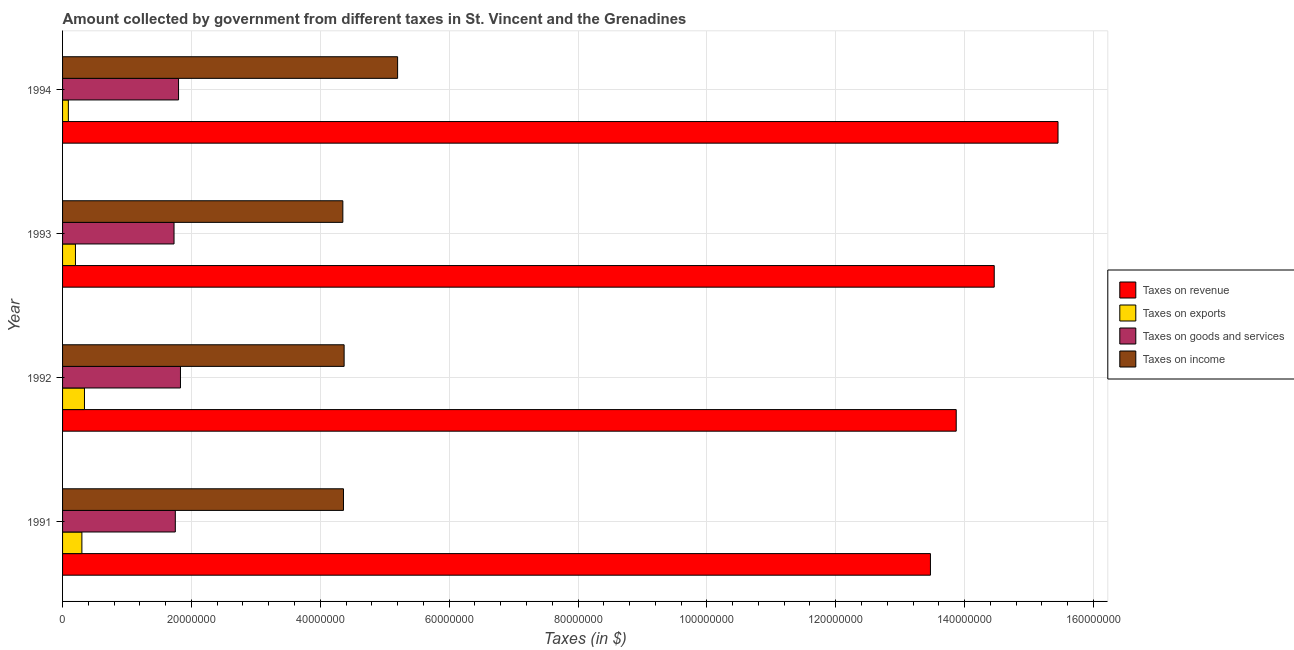How many different coloured bars are there?
Make the answer very short. 4. Are the number of bars per tick equal to the number of legend labels?
Offer a terse response. Yes. Are the number of bars on each tick of the Y-axis equal?
Give a very brief answer. Yes. How many bars are there on the 2nd tick from the top?
Offer a terse response. 4. How many bars are there on the 2nd tick from the bottom?
Your answer should be very brief. 4. What is the label of the 3rd group of bars from the top?
Provide a short and direct response. 1992. What is the amount collected as tax on revenue in 1991?
Your answer should be compact. 1.35e+08. Across all years, what is the maximum amount collected as tax on goods?
Offer a terse response. 1.83e+07. Across all years, what is the minimum amount collected as tax on goods?
Offer a very short reply. 1.73e+07. In which year was the amount collected as tax on revenue minimum?
Your answer should be very brief. 1991. What is the total amount collected as tax on income in the graph?
Your response must be concise. 1.83e+08. What is the difference between the amount collected as tax on goods in 1992 and that in 1994?
Your answer should be very brief. 3.00e+05. What is the difference between the amount collected as tax on exports in 1991 and the amount collected as tax on income in 1992?
Keep it short and to the point. -4.07e+07. What is the average amount collected as tax on goods per year?
Ensure brevity in your answer.  1.78e+07. In the year 1993, what is the difference between the amount collected as tax on exports and amount collected as tax on revenue?
Provide a short and direct response. -1.43e+08. Is the difference between the amount collected as tax on revenue in 1991 and 1994 greater than the difference between the amount collected as tax on exports in 1991 and 1994?
Keep it short and to the point. No. What is the difference between the highest and the second highest amount collected as tax on goods?
Keep it short and to the point. 3.00e+05. What is the difference between the highest and the lowest amount collected as tax on goods?
Your answer should be compact. 1.00e+06. What does the 4th bar from the top in 1993 represents?
Provide a succinct answer. Taxes on revenue. What does the 2nd bar from the bottom in 1992 represents?
Your response must be concise. Taxes on exports. Is it the case that in every year, the sum of the amount collected as tax on revenue and amount collected as tax on exports is greater than the amount collected as tax on goods?
Offer a very short reply. Yes. How many bars are there?
Give a very brief answer. 16. Are the values on the major ticks of X-axis written in scientific E-notation?
Keep it short and to the point. No. Does the graph contain grids?
Your answer should be very brief. Yes. Where does the legend appear in the graph?
Give a very brief answer. Center right. How many legend labels are there?
Make the answer very short. 4. How are the legend labels stacked?
Your answer should be very brief. Vertical. What is the title of the graph?
Keep it short and to the point. Amount collected by government from different taxes in St. Vincent and the Grenadines. What is the label or title of the X-axis?
Give a very brief answer. Taxes (in $). What is the label or title of the Y-axis?
Make the answer very short. Year. What is the Taxes (in $) in Taxes on revenue in 1991?
Your answer should be very brief. 1.35e+08. What is the Taxes (in $) in Taxes on goods and services in 1991?
Ensure brevity in your answer.  1.75e+07. What is the Taxes (in $) in Taxes on income in 1991?
Provide a succinct answer. 4.36e+07. What is the Taxes (in $) of Taxes on revenue in 1992?
Provide a short and direct response. 1.39e+08. What is the Taxes (in $) of Taxes on exports in 1992?
Keep it short and to the point. 3.40e+06. What is the Taxes (in $) in Taxes on goods and services in 1992?
Ensure brevity in your answer.  1.83e+07. What is the Taxes (in $) in Taxes on income in 1992?
Ensure brevity in your answer.  4.37e+07. What is the Taxes (in $) in Taxes on revenue in 1993?
Offer a very short reply. 1.45e+08. What is the Taxes (in $) in Taxes on goods and services in 1993?
Provide a succinct answer. 1.73e+07. What is the Taxes (in $) in Taxes on income in 1993?
Offer a very short reply. 4.35e+07. What is the Taxes (in $) in Taxes on revenue in 1994?
Provide a succinct answer. 1.54e+08. What is the Taxes (in $) in Taxes on exports in 1994?
Your answer should be compact. 9.00e+05. What is the Taxes (in $) of Taxes on goods and services in 1994?
Your answer should be compact. 1.80e+07. What is the Taxes (in $) in Taxes on income in 1994?
Make the answer very short. 5.20e+07. Across all years, what is the maximum Taxes (in $) in Taxes on revenue?
Provide a succinct answer. 1.54e+08. Across all years, what is the maximum Taxes (in $) in Taxes on exports?
Provide a succinct answer. 3.40e+06. Across all years, what is the maximum Taxes (in $) in Taxes on goods and services?
Keep it short and to the point. 1.83e+07. Across all years, what is the maximum Taxes (in $) of Taxes on income?
Your response must be concise. 5.20e+07. Across all years, what is the minimum Taxes (in $) in Taxes on revenue?
Make the answer very short. 1.35e+08. Across all years, what is the minimum Taxes (in $) in Taxes on goods and services?
Your answer should be compact. 1.73e+07. Across all years, what is the minimum Taxes (in $) in Taxes on income?
Ensure brevity in your answer.  4.35e+07. What is the total Taxes (in $) of Taxes on revenue in the graph?
Provide a succinct answer. 5.72e+08. What is the total Taxes (in $) of Taxes on exports in the graph?
Ensure brevity in your answer.  9.30e+06. What is the total Taxes (in $) of Taxes on goods and services in the graph?
Make the answer very short. 7.11e+07. What is the total Taxes (in $) of Taxes on income in the graph?
Provide a short and direct response. 1.83e+08. What is the difference between the Taxes (in $) of Taxes on exports in 1991 and that in 1992?
Your response must be concise. -4.00e+05. What is the difference between the Taxes (in $) of Taxes on goods and services in 1991 and that in 1992?
Provide a short and direct response. -8.00e+05. What is the difference between the Taxes (in $) of Taxes on income in 1991 and that in 1992?
Your answer should be very brief. -1.00e+05. What is the difference between the Taxes (in $) of Taxes on revenue in 1991 and that in 1993?
Your response must be concise. -9.90e+06. What is the difference between the Taxes (in $) of Taxes on exports in 1991 and that in 1993?
Ensure brevity in your answer.  1.00e+06. What is the difference between the Taxes (in $) of Taxes on income in 1991 and that in 1993?
Ensure brevity in your answer.  1.00e+05. What is the difference between the Taxes (in $) in Taxes on revenue in 1991 and that in 1994?
Your answer should be very brief. -1.98e+07. What is the difference between the Taxes (in $) of Taxes on exports in 1991 and that in 1994?
Provide a short and direct response. 2.10e+06. What is the difference between the Taxes (in $) of Taxes on goods and services in 1991 and that in 1994?
Your answer should be compact. -5.00e+05. What is the difference between the Taxes (in $) of Taxes on income in 1991 and that in 1994?
Ensure brevity in your answer.  -8.40e+06. What is the difference between the Taxes (in $) of Taxes on revenue in 1992 and that in 1993?
Keep it short and to the point. -5.90e+06. What is the difference between the Taxes (in $) of Taxes on exports in 1992 and that in 1993?
Your answer should be compact. 1.40e+06. What is the difference between the Taxes (in $) of Taxes on revenue in 1992 and that in 1994?
Your answer should be very brief. -1.58e+07. What is the difference between the Taxes (in $) of Taxes on exports in 1992 and that in 1994?
Provide a succinct answer. 2.50e+06. What is the difference between the Taxes (in $) in Taxes on goods and services in 1992 and that in 1994?
Offer a terse response. 3.00e+05. What is the difference between the Taxes (in $) in Taxes on income in 1992 and that in 1994?
Your answer should be compact. -8.30e+06. What is the difference between the Taxes (in $) in Taxes on revenue in 1993 and that in 1994?
Provide a short and direct response. -9.90e+06. What is the difference between the Taxes (in $) of Taxes on exports in 1993 and that in 1994?
Offer a very short reply. 1.10e+06. What is the difference between the Taxes (in $) in Taxes on goods and services in 1993 and that in 1994?
Give a very brief answer. -7.00e+05. What is the difference between the Taxes (in $) of Taxes on income in 1993 and that in 1994?
Ensure brevity in your answer.  -8.50e+06. What is the difference between the Taxes (in $) of Taxes on revenue in 1991 and the Taxes (in $) of Taxes on exports in 1992?
Ensure brevity in your answer.  1.31e+08. What is the difference between the Taxes (in $) in Taxes on revenue in 1991 and the Taxes (in $) in Taxes on goods and services in 1992?
Give a very brief answer. 1.16e+08. What is the difference between the Taxes (in $) of Taxes on revenue in 1991 and the Taxes (in $) of Taxes on income in 1992?
Your answer should be compact. 9.10e+07. What is the difference between the Taxes (in $) in Taxes on exports in 1991 and the Taxes (in $) in Taxes on goods and services in 1992?
Keep it short and to the point. -1.53e+07. What is the difference between the Taxes (in $) of Taxes on exports in 1991 and the Taxes (in $) of Taxes on income in 1992?
Offer a terse response. -4.07e+07. What is the difference between the Taxes (in $) in Taxes on goods and services in 1991 and the Taxes (in $) in Taxes on income in 1992?
Provide a short and direct response. -2.62e+07. What is the difference between the Taxes (in $) in Taxes on revenue in 1991 and the Taxes (in $) in Taxes on exports in 1993?
Offer a terse response. 1.33e+08. What is the difference between the Taxes (in $) in Taxes on revenue in 1991 and the Taxes (in $) in Taxes on goods and services in 1993?
Your response must be concise. 1.17e+08. What is the difference between the Taxes (in $) of Taxes on revenue in 1991 and the Taxes (in $) of Taxes on income in 1993?
Offer a terse response. 9.12e+07. What is the difference between the Taxes (in $) in Taxes on exports in 1991 and the Taxes (in $) in Taxes on goods and services in 1993?
Your answer should be very brief. -1.43e+07. What is the difference between the Taxes (in $) of Taxes on exports in 1991 and the Taxes (in $) of Taxes on income in 1993?
Provide a succinct answer. -4.05e+07. What is the difference between the Taxes (in $) of Taxes on goods and services in 1991 and the Taxes (in $) of Taxes on income in 1993?
Offer a very short reply. -2.60e+07. What is the difference between the Taxes (in $) of Taxes on revenue in 1991 and the Taxes (in $) of Taxes on exports in 1994?
Ensure brevity in your answer.  1.34e+08. What is the difference between the Taxes (in $) of Taxes on revenue in 1991 and the Taxes (in $) of Taxes on goods and services in 1994?
Offer a terse response. 1.17e+08. What is the difference between the Taxes (in $) of Taxes on revenue in 1991 and the Taxes (in $) of Taxes on income in 1994?
Your answer should be very brief. 8.27e+07. What is the difference between the Taxes (in $) in Taxes on exports in 1991 and the Taxes (in $) in Taxes on goods and services in 1994?
Your response must be concise. -1.50e+07. What is the difference between the Taxes (in $) in Taxes on exports in 1991 and the Taxes (in $) in Taxes on income in 1994?
Ensure brevity in your answer.  -4.90e+07. What is the difference between the Taxes (in $) of Taxes on goods and services in 1991 and the Taxes (in $) of Taxes on income in 1994?
Your answer should be very brief. -3.45e+07. What is the difference between the Taxes (in $) of Taxes on revenue in 1992 and the Taxes (in $) of Taxes on exports in 1993?
Keep it short and to the point. 1.37e+08. What is the difference between the Taxes (in $) of Taxes on revenue in 1992 and the Taxes (in $) of Taxes on goods and services in 1993?
Provide a short and direct response. 1.21e+08. What is the difference between the Taxes (in $) in Taxes on revenue in 1992 and the Taxes (in $) in Taxes on income in 1993?
Give a very brief answer. 9.52e+07. What is the difference between the Taxes (in $) in Taxes on exports in 1992 and the Taxes (in $) in Taxes on goods and services in 1993?
Provide a short and direct response. -1.39e+07. What is the difference between the Taxes (in $) of Taxes on exports in 1992 and the Taxes (in $) of Taxes on income in 1993?
Offer a very short reply. -4.01e+07. What is the difference between the Taxes (in $) of Taxes on goods and services in 1992 and the Taxes (in $) of Taxes on income in 1993?
Offer a terse response. -2.52e+07. What is the difference between the Taxes (in $) in Taxes on revenue in 1992 and the Taxes (in $) in Taxes on exports in 1994?
Offer a very short reply. 1.38e+08. What is the difference between the Taxes (in $) of Taxes on revenue in 1992 and the Taxes (in $) of Taxes on goods and services in 1994?
Provide a succinct answer. 1.21e+08. What is the difference between the Taxes (in $) in Taxes on revenue in 1992 and the Taxes (in $) in Taxes on income in 1994?
Your answer should be compact. 8.67e+07. What is the difference between the Taxes (in $) in Taxes on exports in 1992 and the Taxes (in $) in Taxes on goods and services in 1994?
Keep it short and to the point. -1.46e+07. What is the difference between the Taxes (in $) in Taxes on exports in 1992 and the Taxes (in $) in Taxes on income in 1994?
Ensure brevity in your answer.  -4.86e+07. What is the difference between the Taxes (in $) of Taxes on goods and services in 1992 and the Taxes (in $) of Taxes on income in 1994?
Make the answer very short. -3.37e+07. What is the difference between the Taxes (in $) of Taxes on revenue in 1993 and the Taxes (in $) of Taxes on exports in 1994?
Provide a succinct answer. 1.44e+08. What is the difference between the Taxes (in $) of Taxes on revenue in 1993 and the Taxes (in $) of Taxes on goods and services in 1994?
Your answer should be compact. 1.27e+08. What is the difference between the Taxes (in $) in Taxes on revenue in 1993 and the Taxes (in $) in Taxes on income in 1994?
Provide a succinct answer. 9.26e+07. What is the difference between the Taxes (in $) in Taxes on exports in 1993 and the Taxes (in $) in Taxes on goods and services in 1994?
Ensure brevity in your answer.  -1.60e+07. What is the difference between the Taxes (in $) of Taxes on exports in 1993 and the Taxes (in $) of Taxes on income in 1994?
Your answer should be very brief. -5.00e+07. What is the difference between the Taxes (in $) in Taxes on goods and services in 1993 and the Taxes (in $) in Taxes on income in 1994?
Your answer should be compact. -3.47e+07. What is the average Taxes (in $) in Taxes on revenue per year?
Give a very brief answer. 1.43e+08. What is the average Taxes (in $) in Taxes on exports per year?
Provide a succinct answer. 2.32e+06. What is the average Taxes (in $) of Taxes on goods and services per year?
Your answer should be compact. 1.78e+07. What is the average Taxes (in $) in Taxes on income per year?
Provide a short and direct response. 4.57e+07. In the year 1991, what is the difference between the Taxes (in $) of Taxes on revenue and Taxes (in $) of Taxes on exports?
Give a very brief answer. 1.32e+08. In the year 1991, what is the difference between the Taxes (in $) in Taxes on revenue and Taxes (in $) in Taxes on goods and services?
Provide a succinct answer. 1.17e+08. In the year 1991, what is the difference between the Taxes (in $) in Taxes on revenue and Taxes (in $) in Taxes on income?
Make the answer very short. 9.11e+07. In the year 1991, what is the difference between the Taxes (in $) in Taxes on exports and Taxes (in $) in Taxes on goods and services?
Your answer should be very brief. -1.45e+07. In the year 1991, what is the difference between the Taxes (in $) of Taxes on exports and Taxes (in $) of Taxes on income?
Your response must be concise. -4.06e+07. In the year 1991, what is the difference between the Taxes (in $) in Taxes on goods and services and Taxes (in $) in Taxes on income?
Provide a succinct answer. -2.61e+07. In the year 1992, what is the difference between the Taxes (in $) in Taxes on revenue and Taxes (in $) in Taxes on exports?
Your answer should be compact. 1.35e+08. In the year 1992, what is the difference between the Taxes (in $) in Taxes on revenue and Taxes (in $) in Taxes on goods and services?
Offer a very short reply. 1.20e+08. In the year 1992, what is the difference between the Taxes (in $) of Taxes on revenue and Taxes (in $) of Taxes on income?
Make the answer very short. 9.50e+07. In the year 1992, what is the difference between the Taxes (in $) in Taxes on exports and Taxes (in $) in Taxes on goods and services?
Your answer should be very brief. -1.49e+07. In the year 1992, what is the difference between the Taxes (in $) in Taxes on exports and Taxes (in $) in Taxes on income?
Your response must be concise. -4.03e+07. In the year 1992, what is the difference between the Taxes (in $) of Taxes on goods and services and Taxes (in $) of Taxes on income?
Ensure brevity in your answer.  -2.54e+07. In the year 1993, what is the difference between the Taxes (in $) in Taxes on revenue and Taxes (in $) in Taxes on exports?
Your answer should be compact. 1.43e+08. In the year 1993, what is the difference between the Taxes (in $) of Taxes on revenue and Taxes (in $) of Taxes on goods and services?
Provide a succinct answer. 1.27e+08. In the year 1993, what is the difference between the Taxes (in $) of Taxes on revenue and Taxes (in $) of Taxes on income?
Give a very brief answer. 1.01e+08. In the year 1993, what is the difference between the Taxes (in $) of Taxes on exports and Taxes (in $) of Taxes on goods and services?
Give a very brief answer. -1.53e+07. In the year 1993, what is the difference between the Taxes (in $) of Taxes on exports and Taxes (in $) of Taxes on income?
Give a very brief answer. -4.15e+07. In the year 1993, what is the difference between the Taxes (in $) in Taxes on goods and services and Taxes (in $) in Taxes on income?
Provide a succinct answer. -2.62e+07. In the year 1994, what is the difference between the Taxes (in $) in Taxes on revenue and Taxes (in $) in Taxes on exports?
Make the answer very short. 1.54e+08. In the year 1994, what is the difference between the Taxes (in $) of Taxes on revenue and Taxes (in $) of Taxes on goods and services?
Your answer should be very brief. 1.36e+08. In the year 1994, what is the difference between the Taxes (in $) in Taxes on revenue and Taxes (in $) in Taxes on income?
Your answer should be compact. 1.02e+08. In the year 1994, what is the difference between the Taxes (in $) in Taxes on exports and Taxes (in $) in Taxes on goods and services?
Provide a succinct answer. -1.71e+07. In the year 1994, what is the difference between the Taxes (in $) of Taxes on exports and Taxes (in $) of Taxes on income?
Provide a short and direct response. -5.11e+07. In the year 1994, what is the difference between the Taxes (in $) in Taxes on goods and services and Taxes (in $) in Taxes on income?
Make the answer very short. -3.40e+07. What is the ratio of the Taxes (in $) in Taxes on revenue in 1991 to that in 1992?
Your answer should be compact. 0.97. What is the ratio of the Taxes (in $) of Taxes on exports in 1991 to that in 1992?
Your answer should be compact. 0.88. What is the ratio of the Taxes (in $) in Taxes on goods and services in 1991 to that in 1992?
Your answer should be very brief. 0.96. What is the ratio of the Taxes (in $) in Taxes on income in 1991 to that in 1992?
Make the answer very short. 1. What is the ratio of the Taxes (in $) in Taxes on revenue in 1991 to that in 1993?
Make the answer very short. 0.93. What is the ratio of the Taxes (in $) of Taxes on exports in 1991 to that in 1993?
Your answer should be very brief. 1.5. What is the ratio of the Taxes (in $) in Taxes on goods and services in 1991 to that in 1993?
Give a very brief answer. 1.01. What is the ratio of the Taxes (in $) of Taxes on income in 1991 to that in 1993?
Your response must be concise. 1. What is the ratio of the Taxes (in $) in Taxes on revenue in 1991 to that in 1994?
Provide a succinct answer. 0.87. What is the ratio of the Taxes (in $) of Taxes on goods and services in 1991 to that in 1994?
Your answer should be compact. 0.97. What is the ratio of the Taxes (in $) of Taxes on income in 1991 to that in 1994?
Your response must be concise. 0.84. What is the ratio of the Taxes (in $) in Taxes on revenue in 1992 to that in 1993?
Give a very brief answer. 0.96. What is the ratio of the Taxes (in $) of Taxes on goods and services in 1992 to that in 1993?
Keep it short and to the point. 1.06. What is the ratio of the Taxes (in $) in Taxes on revenue in 1992 to that in 1994?
Your answer should be compact. 0.9. What is the ratio of the Taxes (in $) in Taxes on exports in 1992 to that in 1994?
Ensure brevity in your answer.  3.78. What is the ratio of the Taxes (in $) of Taxes on goods and services in 1992 to that in 1994?
Your answer should be compact. 1.02. What is the ratio of the Taxes (in $) in Taxes on income in 1992 to that in 1994?
Make the answer very short. 0.84. What is the ratio of the Taxes (in $) of Taxes on revenue in 1993 to that in 1994?
Keep it short and to the point. 0.94. What is the ratio of the Taxes (in $) of Taxes on exports in 1993 to that in 1994?
Keep it short and to the point. 2.22. What is the ratio of the Taxes (in $) in Taxes on goods and services in 1993 to that in 1994?
Your response must be concise. 0.96. What is the ratio of the Taxes (in $) in Taxes on income in 1993 to that in 1994?
Offer a very short reply. 0.84. What is the difference between the highest and the second highest Taxes (in $) in Taxes on revenue?
Give a very brief answer. 9.90e+06. What is the difference between the highest and the second highest Taxes (in $) of Taxes on exports?
Offer a very short reply. 4.00e+05. What is the difference between the highest and the second highest Taxes (in $) of Taxes on goods and services?
Offer a very short reply. 3.00e+05. What is the difference between the highest and the second highest Taxes (in $) of Taxes on income?
Your answer should be very brief. 8.30e+06. What is the difference between the highest and the lowest Taxes (in $) of Taxes on revenue?
Ensure brevity in your answer.  1.98e+07. What is the difference between the highest and the lowest Taxes (in $) in Taxes on exports?
Offer a terse response. 2.50e+06. What is the difference between the highest and the lowest Taxes (in $) in Taxes on goods and services?
Ensure brevity in your answer.  1.00e+06. What is the difference between the highest and the lowest Taxes (in $) of Taxes on income?
Ensure brevity in your answer.  8.50e+06. 